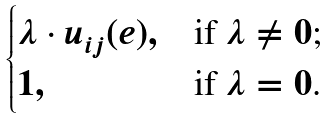Convert formula to latex. <formula><loc_0><loc_0><loc_500><loc_500>\begin{cases} \lambda \cdot u _ { i j } ( e ) , & \text {if $\lambda \neq 0$;} \\ 1 , & \text {if $\lambda = 0$.} \end{cases}</formula> 